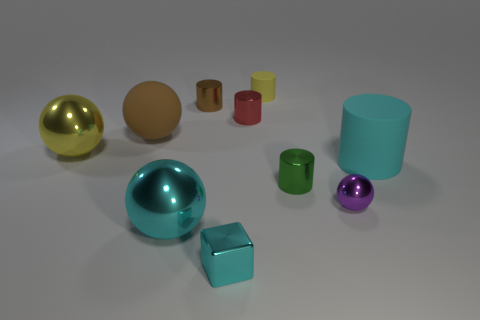The cyan object that is the same material as the big brown object is what size?
Offer a terse response. Large. How many red shiny objects have the same shape as the yellow shiny thing?
Provide a short and direct response. 0. There is a tiny green object; is it the same shape as the rubber object left of the red cylinder?
Your answer should be very brief. No. The small thing that is the same color as the large matte ball is what shape?
Your answer should be very brief. Cylinder. Is there a sphere made of the same material as the tiny brown object?
Offer a terse response. Yes. There is a small cylinder that is in front of the object right of the small ball; what is its material?
Your answer should be compact. Metal. There is a rubber cylinder that is in front of the large metal ball that is behind the small cylinder right of the yellow rubber object; what is its size?
Provide a succinct answer. Large. What number of other objects are there of the same shape as the yellow matte object?
Your answer should be very brief. 4. Is the color of the big rubber thing that is right of the small cyan block the same as the big sphere in front of the big yellow ball?
Offer a terse response. Yes. What is the color of the rubber sphere that is the same size as the cyan rubber cylinder?
Keep it short and to the point. Brown. 